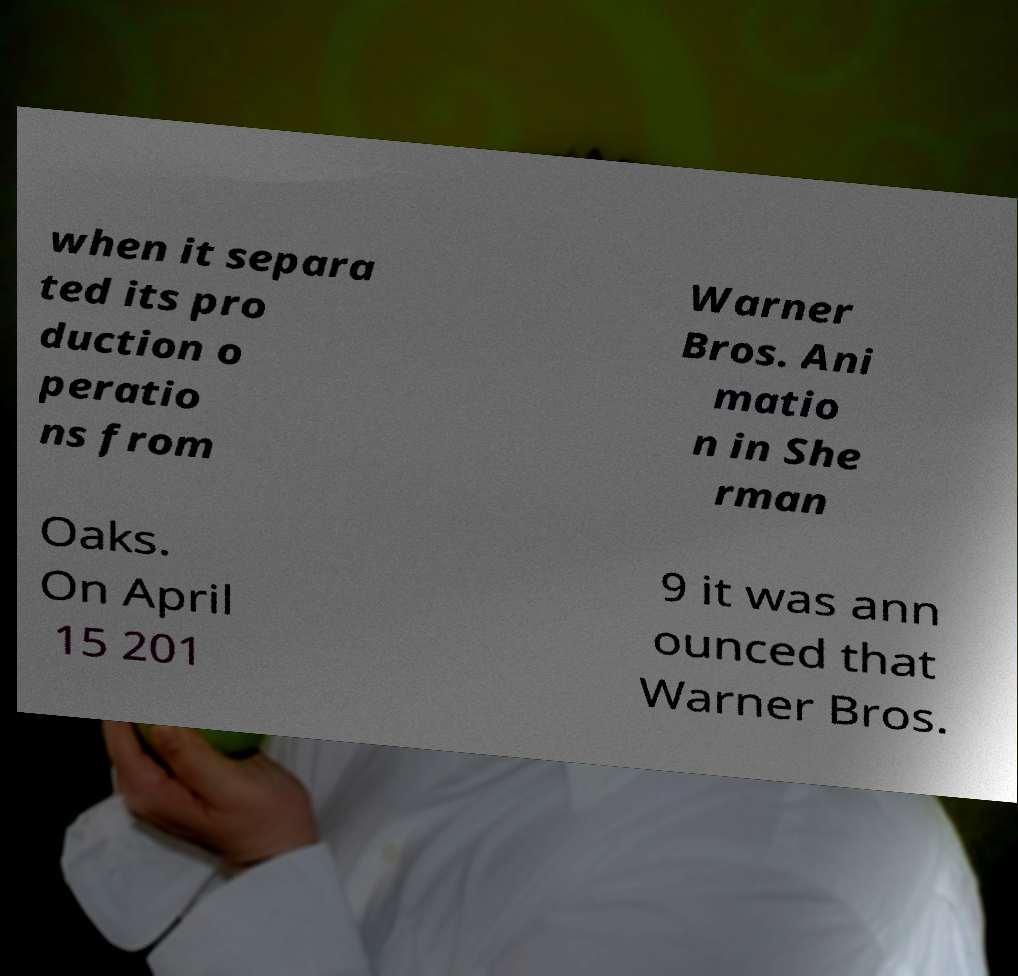There's text embedded in this image that I need extracted. Can you transcribe it verbatim? when it separa ted its pro duction o peratio ns from Warner Bros. Ani matio n in She rman Oaks. On April 15 201 9 it was ann ounced that Warner Bros. 